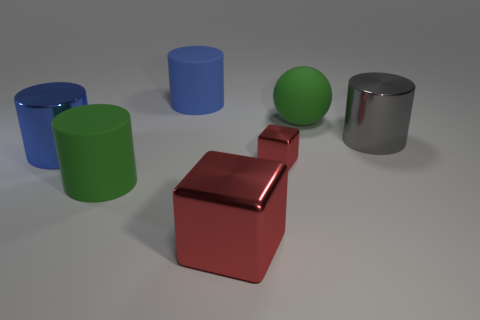Add 3 balls. How many objects exist? 10 Subtract all cubes. How many objects are left? 5 Subtract 0 yellow balls. How many objects are left? 7 Subtract all large blue matte balls. Subtract all rubber spheres. How many objects are left? 6 Add 2 rubber cylinders. How many rubber cylinders are left? 4 Add 3 big brown rubber objects. How many big brown rubber objects exist? 3 